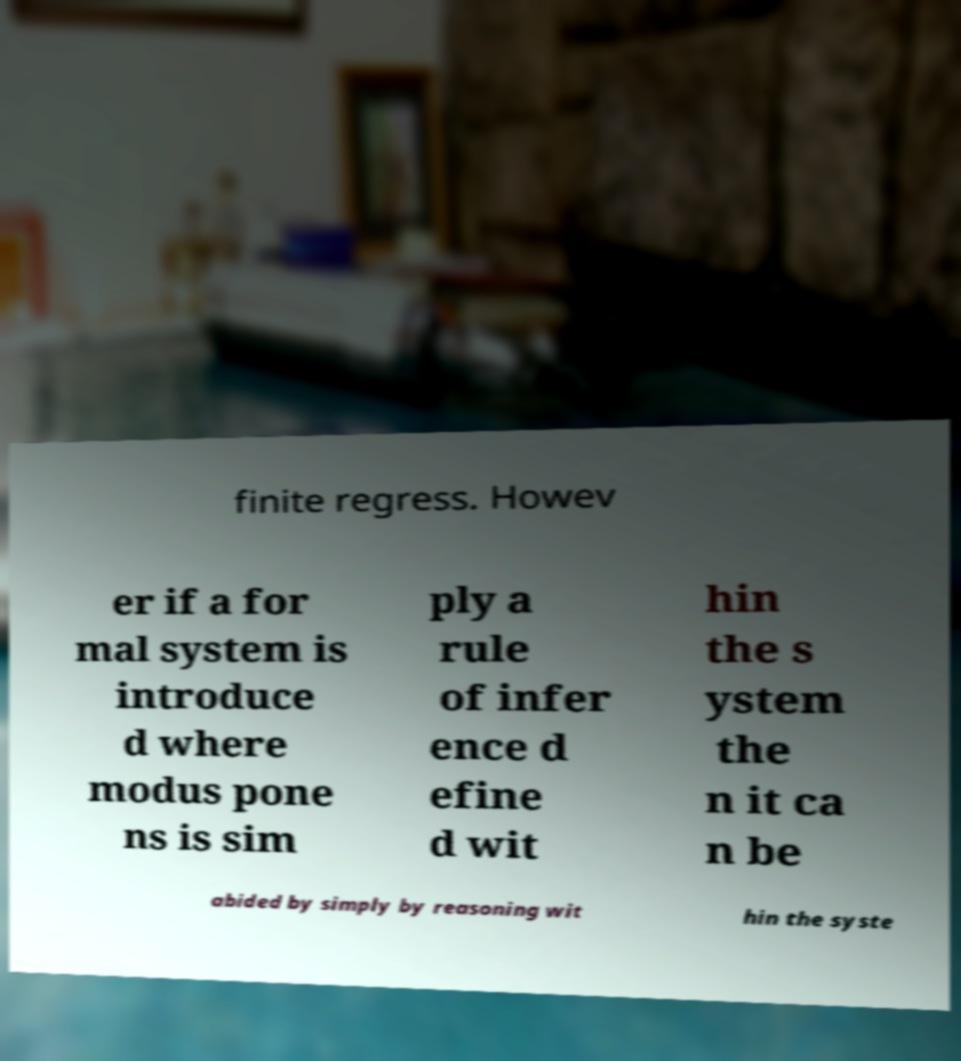Can you read and provide the text displayed in the image?This photo seems to have some interesting text. Can you extract and type it out for me? finite regress. Howev er if a for mal system is introduce d where modus pone ns is sim ply a rule of infer ence d efine d wit hin the s ystem the n it ca n be abided by simply by reasoning wit hin the syste 